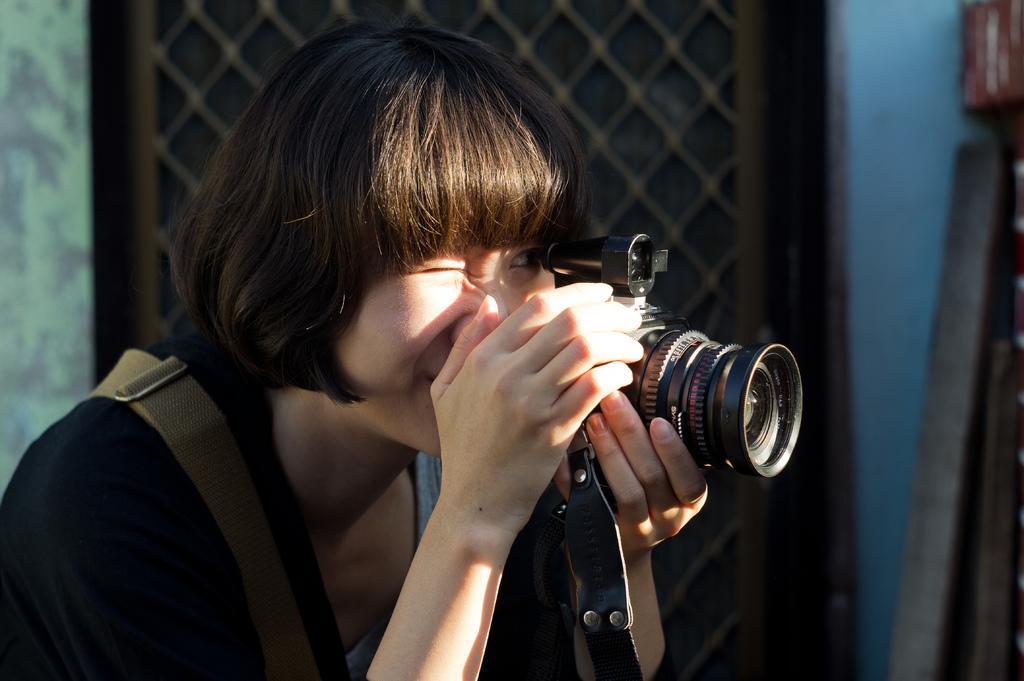How would you summarize this image in a sentence or two? in the picture a woman is catching a camera. 